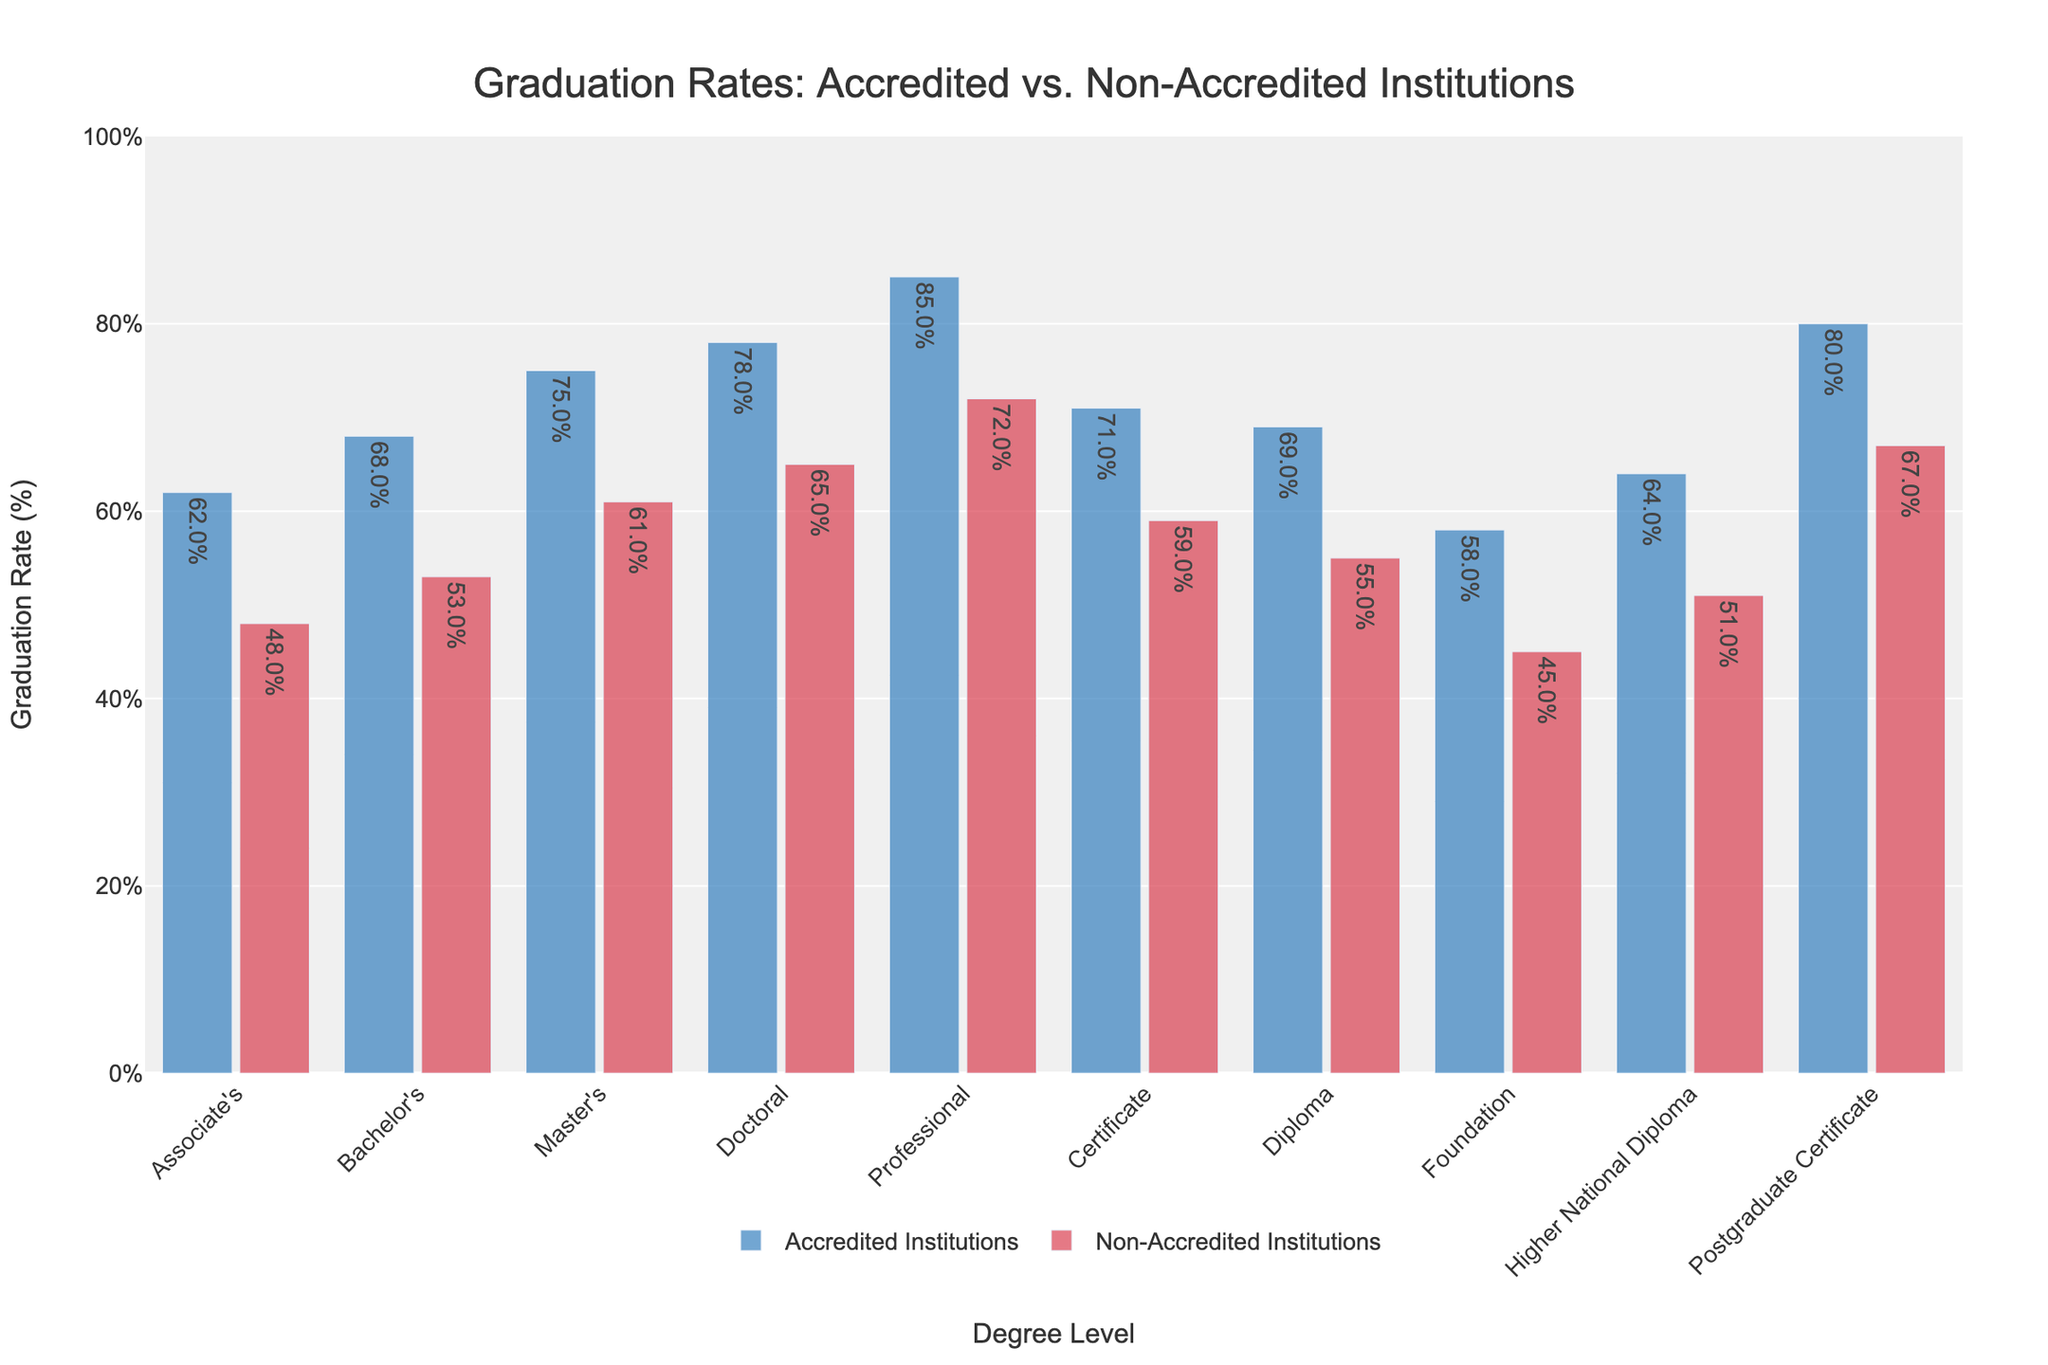What is the graduation rate difference between accredited and non-accredited institutions for Bachelor's degrees? The graduation rate for Bachelor's degrees at accredited institutions is 68%, while at non-accredited institutions, it is 53%. The difference is found by subtracting 53% from 68%.
Answer: 15% Which degree level has the highest graduation rate at non-accredited institutions? By examining the bars for non-accredited institutions, the Professional degree level has the tallest bar, indicating the highest graduation rate of 72%.
Answer: Professional Do accredited institutions have a higher graduation rate for Associate's degrees than non-accredited institutions for Doctoral degrees? The graduation rate for Associate's degrees at accredited institutions is 62%, and for Doctoral degrees at non-accredited institutions, it is 65%. Comparing these values, 62% is less than 65%.
Answer: No For which degree level is the difference in graduation rates between accredited and non-accredited institutions the smallest? By comparing the differences for each degree level, the Graduate Certificate has the smallest difference of 13% (80% - 67%).
Answer: Graduate Certificate How many degree levels have a graduation rate of at least 70% at accredited institutions? By reviewing the graduation rates for accredited institutions, the Professional (85%), Postgraduate Certificate (80%), and Master's (75%) degrees exceed 70%, along with Certificate (71%) and Diploma (69%), totaling 5 degree levels.
Answer: 5 Which degree level shows the greatest gap in graduation rates between accredited and non-accredited institutions? The Professional degree level shows the largest gap with a difference of 13% (85% for accredited minus 72% for non-accredited).
Answer: Professional Are the graduation rates for Foundation degrees higher at accredited institutions than the undergraduate diplomas at non-accredited institutions? The graduation rate for Foundation degrees at accredited institutions is 58%, whereas for Higher National Diplomas at non-accredited institutions (considered an undergraduate diploma), it is 51%. Comparing these, 58% is higher than 51%.
Answer: Yes 